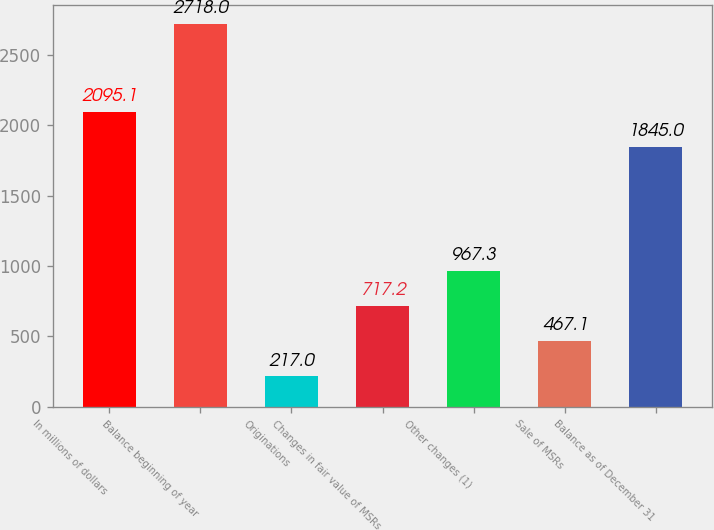<chart> <loc_0><loc_0><loc_500><loc_500><bar_chart><fcel>In millions of dollars<fcel>Balance beginning of year<fcel>Originations<fcel>Changes in fair value of MSRs<fcel>Other changes (1)<fcel>Sale of MSRs<fcel>Balance as of December 31<nl><fcel>2095.1<fcel>2718<fcel>217<fcel>717.2<fcel>967.3<fcel>467.1<fcel>1845<nl></chart> 